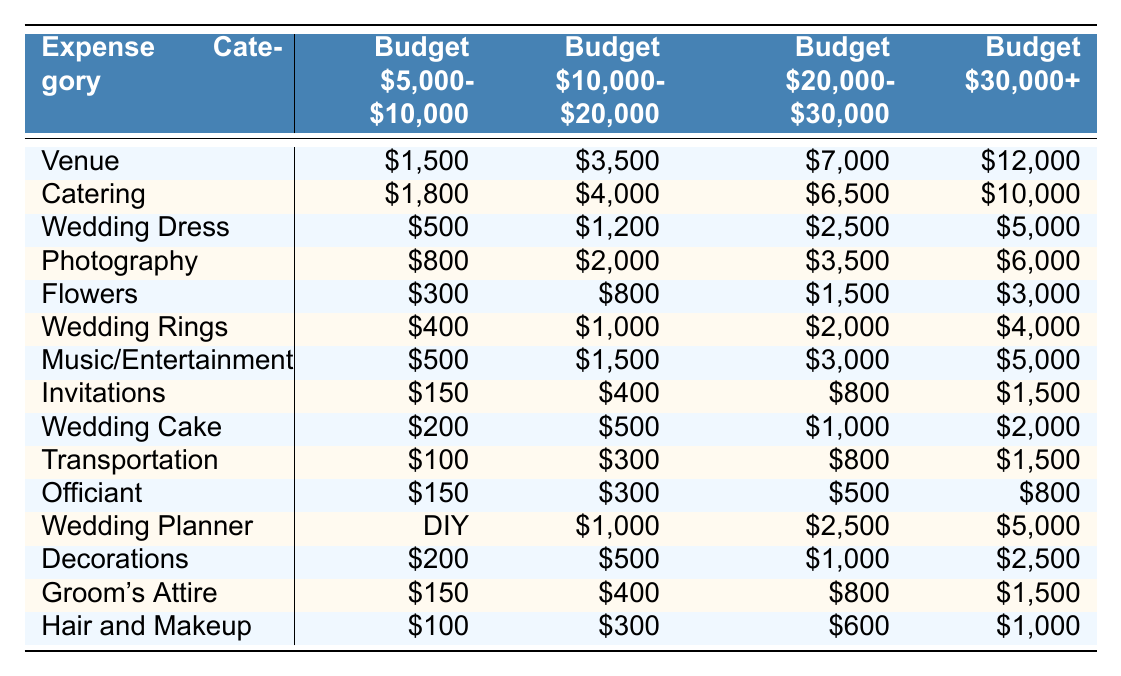What is the average expense for a wedding dress in the budget range of $10,000 to $20,000? According to the table, the average expense for a wedding dress in this budget range is $1,200.
Answer: $1,200 Which expense category has the highest cost in the budget range of $30,000 and above? The venue has the highest cost in this budget range at $12,000.
Answer: $12,000 Is the cost of the officiant higher in the budget range of $20,000 to $30,000 compared to the budget range of $10,000 to $20,000? For the budget range of $20,000 to $30,000, the officiant cost is $500, while in the $10,000 to $20,000 range, it is $300. Therefore, the cost is higher in the $20,000 to $30,000 range.
Answer: Yes What is the total expense for flowers and decorations in the budget range of $5,000 to $10,000? In the $5,000 to $10,000 budget range, flowers cost $300 and decorations cost $200. Adding these together gives $300 + $200 = $500.
Answer: $500 In which budget category is the cost of the wedding planner the lowest? The wedding planner cost is lowest in the $5,000 to $10,000 budget category as it is listed as "DIY" (no cost associated indicated).
Answer: $0 (DIY) What is the difference in average expenses between catering and photography in the budget range of $20,000 to $30,000? Catering costs $6,500 and photography costs $3,500 in this range. The difference is $6,500 - $3,500 = $3,000.
Answer: $3,000 Which expense category has the least average cost in the $10,000 to $20,000 budget range? The lowest expense category in this budget range is invitations, which cost $400.
Answer: $400 What is the combined cost of the wedding dress, rings, and hair and makeup in the $30,000 and above budget range? The wedding dress costs $5,000, wedding rings cost $4,000, and hair and makeup costs $1,000 in this range. The total is $5,000 + $4,000 + $1,000 = $10,000.
Answer: $10,000 Is the average cost for transportation higher in the $10,000 to $20,000 budget category than in the $30,000 and above category? The transportation cost is $300 in the $10,000 to $20,000 range and $1,500 in the $30,000 and above range. Therefore, it is higher in the $30,000 and above range.
Answer: No What is the average expense for flowers across all budget ranges? Flower costs across the budget ranges are $300, $800, $1,500, and $3,000. Summing these gives $300 + $800 + $1,500 + $3,000 = $5,600. There are four ranges, so the average is $5,600 / 4 = $1,400.
Answer: $1,400 